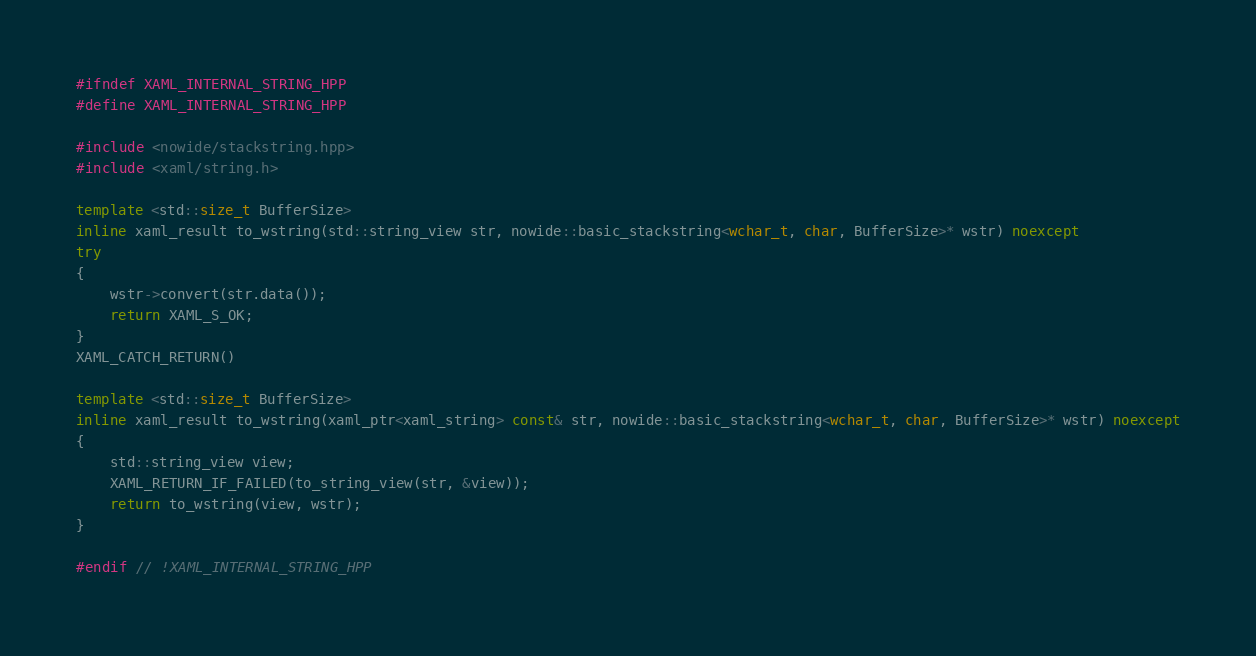<code> <loc_0><loc_0><loc_500><loc_500><_C++_>#ifndef XAML_INTERNAL_STRING_HPP
#define XAML_INTERNAL_STRING_HPP

#include <nowide/stackstring.hpp>
#include <xaml/string.h>

template <std::size_t BufferSize>
inline xaml_result to_wstring(std::string_view str, nowide::basic_stackstring<wchar_t, char, BufferSize>* wstr) noexcept
try
{
    wstr->convert(str.data());
    return XAML_S_OK;
}
XAML_CATCH_RETURN()

template <std::size_t BufferSize>
inline xaml_result to_wstring(xaml_ptr<xaml_string> const& str, nowide::basic_stackstring<wchar_t, char, BufferSize>* wstr) noexcept
{
    std::string_view view;
    XAML_RETURN_IF_FAILED(to_string_view(str, &view));
    return to_wstring(view, wstr);
}

#endif // !XAML_INTERNAL_STRING_HPP
</code> 